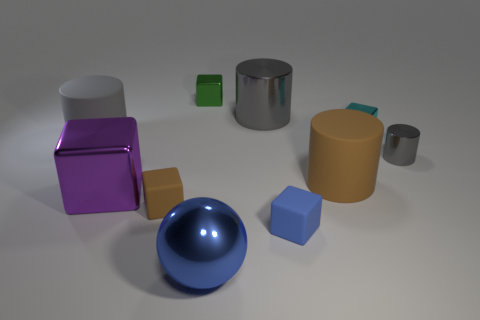There is a green metallic block that is behind the blue ball; is its size the same as the cyan block that is behind the large blue metal thing?
Your response must be concise. Yes. How many gray things are the same material as the small blue block?
Provide a short and direct response. 1. There is a brown thing that is on the left side of the matte cylinder that is in front of the small cylinder; how many big blue shiny spheres are behind it?
Your response must be concise. 0. Is the shape of the large purple object the same as the blue rubber thing?
Ensure brevity in your answer.  Yes. Is there another matte object of the same shape as the blue matte thing?
Keep it short and to the point. Yes. What is the shape of the purple thing that is the same size as the blue shiny sphere?
Offer a very short reply. Cube. What is the material of the large gray cylinder on the right side of the small shiny block left of the big cylinder behind the gray matte cylinder?
Give a very brief answer. Metal. Is the green shiny thing the same size as the gray matte cylinder?
Offer a terse response. No. What is the big brown cylinder made of?
Ensure brevity in your answer.  Rubber. What is the material of the tiny cube that is the same color as the large metallic sphere?
Your response must be concise. Rubber. 